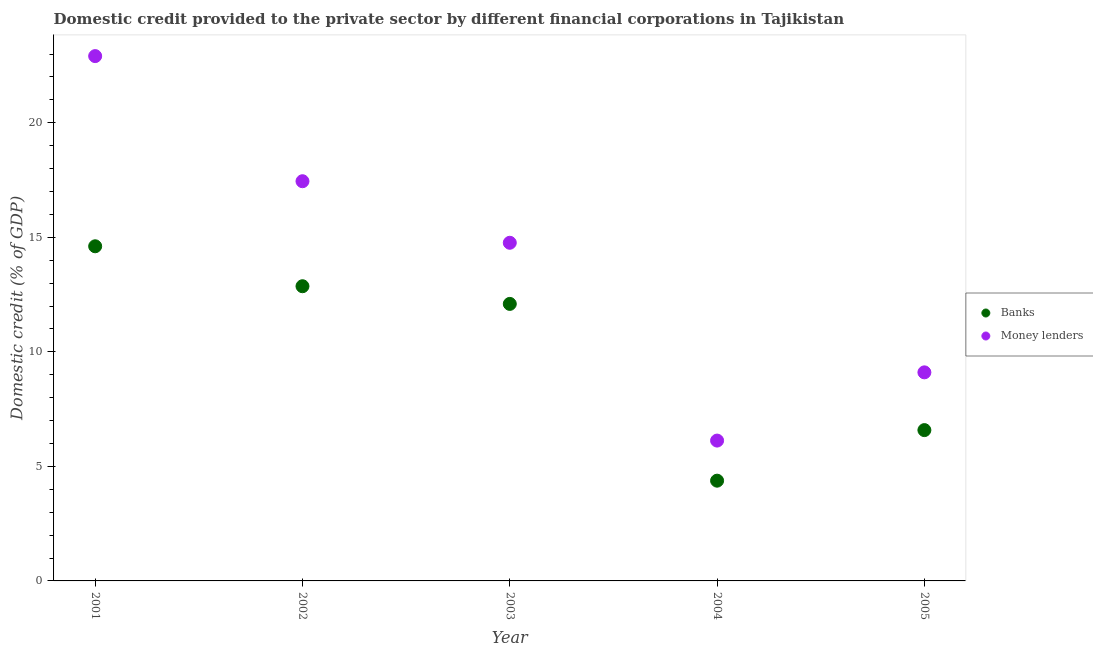What is the domestic credit provided by money lenders in 2003?
Provide a succinct answer. 14.76. Across all years, what is the maximum domestic credit provided by banks?
Your response must be concise. 14.61. Across all years, what is the minimum domestic credit provided by money lenders?
Your answer should be compact. 6.13. In which year was the domestic credit provided by banks maximum?
Your answer should be compact. 2001. In which year was the domestic credit provided by money lenders minimum?
Keep it short and to the point. 2004. What is the total domestic credit provided by money lenders in the graph?
Keep it short and to the point. 70.35. What is the difference between the domestic credit provided by banks in 2003 and that in 2004?
Keep it short and to the point. 7.72. What is the difference between the domestic credit provided by banks in 2002 and the domestic credit provided by money lenders in 2004?
Your answer should be very brief. 6.74. What is the average domestic credit provided by money lenders per year?
Your answer should be compact. 14.07. In the year 2004, what is the difference between the domestic credit provided by money lenders and domestic credit provided by banks?
Your response must be concise. 1.75. In how many years, is the domestic credit provided by money lenders greater than 15 %?
Your answer should be compact. 2. What is the ratio of the domestic credit provided by banks in 2001 to that in 2005?
Ensure brevity in your answer.  2.22. Is the domestic credit provided by banks in 2001 less than that in 2003?
Your answer should be very brief. No. What is the difference between the highest and the second highest domestic credit provided by money lenders?
Ensure brevity in your answer.  5.46. What is the difference between the highest and the lowest domestic credit provided by banks?
Make the answer very short. 10.23. In how many years, is the domestic credit provided by money lenders greater than the average domestic credit provided by money lenders taken over all years?
Offer a very short reply. 3. Is the sum of the domestic credit provided by money lenders in 2002 and 2005 greater than the maximum domestic credit provided by banks across all years?
Your answer should be compact. Yes. How many years are there in the graph?
Your response must be concise. 5. Are the values on the major ticks of Y-axis written in scientific E-notation?
Provide a short and direct response. No. Does the graph contain any zero values?
Offer a very short reply. No. How many legend labels are there?
Ensure brevity in your answer.  2. What is the title of the graph?
Give a very brief answer. Domestic credit provided to the private sector by different financial corporations in Tajikistan. What is the label or title of the Y-axis?
Make the answer very short. Domestic credit (% of GDP). What is the Domestic credit (% of GDP) in Banks in 2001?
Your answer should be compact. 14.61. What is the Domestic credit (% of GDP) in Money lenders in 2001?
Offer a terse response. 22.91. What is the Domestic credit (% of GDP) in Banks in 2002?
Offer a very short reply. 12.86. What is the Domestic credit (% of GDP) in Money lenders in 2002?
Your answer should be compact. 17.45. What is the Domestic credit (% of GDP) in Banks in 2003?
Make the answer very short. 12.09. What is the Domestic credit (% of GDP) in Money lenders in 2003?
Your response must be concise. 14.76. What is the Domestic credit (% of GDP) in Banks in 2004?
Ensure brevity in your answer.  4.38. What is the Domestic credit (% of GDP) in Money lenders in 2004?
Your answer should be compact. 6.13. What is the Domestic credit (% of GDP) in Banks in 2005?
Give a very brief answer. 6.58. What is the Domestic credit (% of GDP) in Money lenders in 2005?
Provide a short and direct response. 9.11. Across all years, what is the maximum Domestic credit (% of GDP) of Banks?
Your answer should be compact. 14.61. Across all years, what is the maximum Domestic credit (% of GDP) in Money lenders?
Provide a succinct answer. 22.91. Across all years, what is the minimum Domestic credit (% of GDP) in Banks?
Your answer should be very brief. 4.38. Across all years, what is the minimum Domestic credit (% of GDP) in Money lenders?
Offer a terse response. 6.13. What is the total Domestic credit (% of GDP) in Banks in the graph?
Your answer should be very brief. 50.53. What is the total Domestic credit (% of GDP) in Money lenders in the graph?
Provide a short and direct response. 70.35. What is the difference between the Domestic credit (% of GDP) in Banks in 2001 and that in 2002?
Ensure brevity in your answer.  1.74. What is the difference between the Domestic credit (% of GDP) in Money lenders in 2001 and that in 2002?
Your response must be concise. 5.46. What is the difference between the Domestic credit (% of GDP) in Banks in 2001 and that in 2003?
Make the answer very short. 2.52. What is the difference between the Domestic credit (% of GDP) of Money lenders in 2001 and that in 2003?
Keep it short and to the point. 8.15. What is the difference between the Domestic credit (% of GDP) in Banks in 2001 and that in 2004?
Your answer should be compact. 10.23. What is the difference between the Domestic credit (% of GDP) in Money lenders in 2001 and that in 2004?
Provide a short and direct response. 16.78. What is the difference between the Domestic credit (% of GDP) of Banks in 2001 and that in 2005?
Keep it short and to the point. 8.03. What is the difference between the Domestic credit (% of GDP) of Money lenders in 2001 and that in 2005?
Your response must be concise. 13.81. What is the difference between the Domestic credit (% of GDP) in Banks in 2002 and that in 2003?
Your response must be concise. 0.77. What is the difference between the Domestic credit (% of GDP) in Money lenders in 2002 and that in 2003?
Give a very brief answer. 2.69. What is the difference between the Domestic credit (% of GDP) of Banks in 2002 and that in 2004?
Make the answer very short. 8.49. What is the difference between the Domestic credit (% of GDP) in Money lenders in 2002 and that in 2004?
Give a very brief answer. 11.32. What is the difference between the Domestic credit (% of GDP) of Banks in 2002 and that in 2005?
Your answer should be compact. 6.28. What is the difference between the Domestic credit (% of GDP) in Money lenders in 2002 and that in 2005?
Provide a succinct answer. 8.34. What is the difference between the Domestic credit (% of GDP) in Banks in 2003 and that in 2004?
Make the answer very short. 7.72. What is the difference between the Domestic credit (% of GDP) of Money lenders in 2003 and that in 2004?
Ensure brevity in your answer.  8.64. What is the difference between the Domestic credit (% of GDP) of Banks in 2003 and that in 2005?
Offer a terse response. 5.51. What is the difference between the Domestic credit (% of GDP) of Money lenders in 2003 and that in 2005?
Your response must be concise. 5.66. What is the difference between the Domestic credit (% of GDP) in Banks in 2004 and that in 2005?
Ensure brevity in your answer.  -2.21. What is the difference between the Domestic credit (% of GDP) of Money lenders in 2004 and that in 2005?
Your answer should be compact. -2.98. What is the difference between the Domestic credit (% of GDP) of Banks in 2001 and the Domestic credit (% of GDP) of Money lenders in 2002?
Your answer should be compact. -2.84. What is the difference between the Domestic credit (% of GDP) of Banks in 2001 and the Domestic credit (% of GDP) of Money lenders in 2003?
Give a very brief answer. -0.15. What is the difference between the Domestic credit (% of GDP) in Banks in 2001 and the Domestic credit (% of GDP) in Money lenders in 2004?
Ensure brevity in your answer.  8.48. What is the difference between the Domestic credit (% of GDP) of Banks in 2001 and the Domestic credit (% of GDP) of Money lenders in 2005?
Your answer should be compact. 5.5. What is the difference between the Domestic credit (% of GDP) of Banks in 2002 and the Domestic credit (% of GDP) of Money lenders in 2003?
Keep it short and to the point. -1.9. What is the difference between the Domestic credit (% of GDP) of Banks in 2002 and the Domestic credit (% of GDP) of Money lenders in 2004?
Provide a short and direct response. 6.74. What is the difference between the Domestic credit (% of GDP) of Banks in 2002 and the Domestic credit (% of GDP) of Money lenders in 2005?
Offer a terse response. 3.76. What is the difference between the Domestic credit (% of GDP) of Banks in 2003 and the Domestic credit (% of GDP) of Money lenders in 2004?
Your response must be concise. 5.97. What is the difference between the Domestic credit (% of GDP) of Banks in 2003 and the Domestic credit (% of GDP) of Money lenders in 2005?
Ensure brevity in your answer.  2.99. What is the difference between the Domestic credit (% of GDP) in Banks in 2004 and the Domestic credit (% of GDP) in Money lenders in 2005?
Keep it short and to the point. -4.73. What is the average Domestic credit (% of GDP) in Banks per year?
Offer a terse response. 10.11. What is the average Domestic credit (% of GDP) of Money lenders per year?
Your answer should be very brief. 14.07. In the year 2001, what is the difference between the Domestic credit (% of GDP) of Banks and Domestic credit (% of GDP) of Money lenders?
Provide a succinct answer. -8.3. In the year 2002, what is the difference between the Domestic credit (% of GDP) of Banks and Domestic credit (% of GDP) of Money lenders?
Ensure brevity in your answer.  -4.58. In the year 2003, what is the difference between the Domestic credit (% of GDP) of Banks and Domestic credit (% of GDP) of Money lenders?
Ensure brevity in your answer.  -2.67. In the year 2004, what is the difference between the Domestic credit (% of GDP) in Banks and Domestic credit (% of GDP) in Money lenders?
Your response must be concise. -1.75. In the year 2005, what is the difference between the Domestic credit (% of GDP) of Banks and Domestic credit (% of GDP) of Money lenders?
Ensure brevity in your answer.  -2.52. What is the ratio of the Domestic credit (% of GDP) of Banks in 2001 to that in 2002?
Give a very brief answer. 1.14. What is the ratio of the Domestic credit (% of GDP) in Money lenders in 2001 to that in 2002?
Your answer should be very brief. 1.31. What is the ratio of the Domestic credit (% of GDP) of Banks in 2001 to that in 2003?
Offer a very short reply. 1.21. What is the ratio of the Domestic credit (% of GDP) of Money lenders in 2001 to that in 2003?
Provide a succinct answer. 1.55. What is the ratio of the Domestic credit (% of GDP) of Banks in 2001 to that in 2004?
Make the answer very short. 3.34. What is the ratio of the Domestic credit (% of GDP) in Money lenders in 2001 to that in 2004?
Make the answer very short. 3.74. What is the ratio of the Domestic credit (% of GDP) in Banks in 2001 to that in 2005?
Provide a short and direct response. 2.22. What is the ratio of the Domestic credit (% of GDP) in Money lenders in 2001 to that in 2005?
Your answer should be very brief. 2.52. What is the ratio of the Domestic credit (% of GDP) in Banks in 2002 to that in 2003?
Offer a very short reply. 1.06. What is the ratio of the Domestic credit (% of GDP) of Money lenders in 2002 to that in 2003?
Keep it short and to the point. 1.18. What is the ratio of the Domestic credit (% of GDP) in Banks in 2002 to that in 2004?
Provide a succinct answer. 2.94. What is the ratio of the Domestic credit (% of GDP) in Money lenders in 2002 to that in 2004?
Ensure brevity in your answer.  2.85. What is the ratio of the Domestic credit (% of GDP) in Banks in 2002 to that in 2005?
Offer a very short reply. 1.95. What is the ratio of the Domestic credit (% of GDP) in Money lenders in 2002 to that in 2005?
Your answer should be compact. 1.92. What is the ratio of the Domestic credit (% of GDP) of Banks in 2003 to that in 2004?
Provide a short and direct response. 2.76. What is the ratio of the Domestic credit (% of GDP) of Money lenders in 2003 to that in 2004?
Keep it short and to the point. 2.41. What is the ratio of the Domestic credit (% of GDP) in Banks in 2003 to that in 2005?
Your answer should be compact. 1.84. What is the ratio of the Domestic credit (% of GDP) of Money lenders in 2003 to that in 2005?
Your answer should be compact. 1.62. What is the ratio of the Domestic credit (% of GDP) in Banks in 2004 to that in 2005?
Give a very brief answer. 0.66. What is the ratio of the Domestic credit (% of GDP) in Money lenders in 2004 to that in 2005?
Keep it short and to the point. 0.67. What is the difference between the highest and the second highest Domestic credit (% of GDP) of Banks?
Provide a short and direct response. 1.74. What is the difference between the highest and the second highest Domestic credit (% of GDP) of Money lenders?
Provide a succinct answer. 5.46. What is the difference between the highest and the lowest Domestic credit (% of GDP) of Banks?
Provide a short and direct response. 10.23. What is the difference between the highest and the lowest Domestic credit (% of GDP) in Money lenders?
Keep it short and to the point. 16.78. 